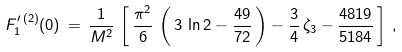Convert formula to latex. <formula><loc_0><loc_0><loc_500><loc_500>F _ { 1 } ^ { \prime \, ( 2 ) } ( 0 ) \, = \, \frac { 1 } { M ^ { 2 } } \, \left [ \, \frac { { { \pi } ^ { 2 } } } { 6 } \, \left ( \, 3 \, \ln 2 - \frac { 4 9 } { 7 2 } \, \right ) - \frac { 3 } { 4 } \, \zeta _ { 3 } - \frac { 4 8 1 9 } { 5 1 8 4 } \, \right ] \, ,</formula> 